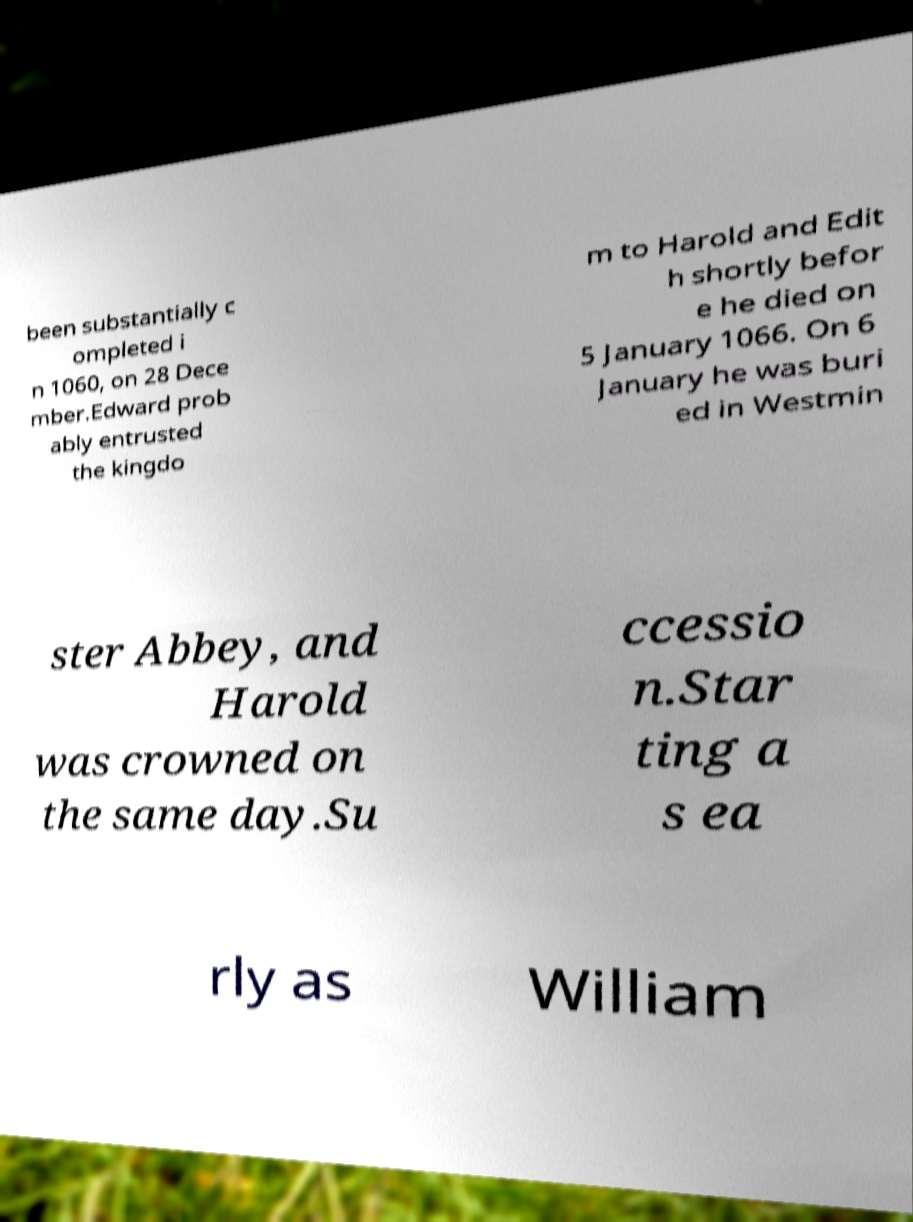There's text embedded in this image that I need extracted. Can you transcribe it verbatim? been substantially c ompleted i n 1060, on 28 Dece mber.Edward prob ably entrusted the kingdo m to Harold and Edit h shortly befor e he died on 5 January 1066. On 6 January he was buri ed in Westmin ster Abbey, and Harold was crowned on the same day.Su ccessio n.Star ting a s ea rly as William 